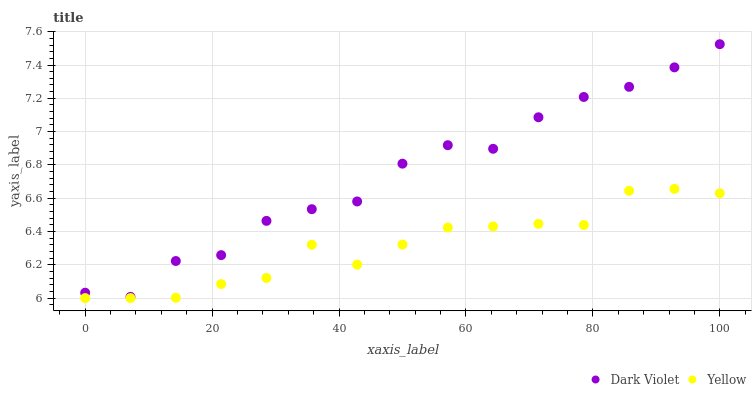Does Yellow have the minimum area under the curve?
Answer yes or no. Yes. Does Dark Violet have the maximum area under the curve?
Answer yes or no. Yes. Does Dark Violet have the minimum area under the curve?
Answer yes or no. No. Is Yellow the smoothest?
Answer yes or no. Yes. Is Dark Violet the roughest?
Answer yes or no. Yes. Is Dark Violet the smoothest?
Answer yes or no. No. Does Yellow have the lowest value?
Answer yes or no. Yes. Does Dark Violet have the lowest value?
Answer yes or no. No. Does Dark Violet have the highest value?
Answer yes or no. Yes. Is Yellow less than Dark Violet?
Answer yes or no. Yes. Is Dark Violet greater than Yellow?
Answer yes or no. Yes. Does Yellow intersect Dark Violet?
Answer yes or no. No. 